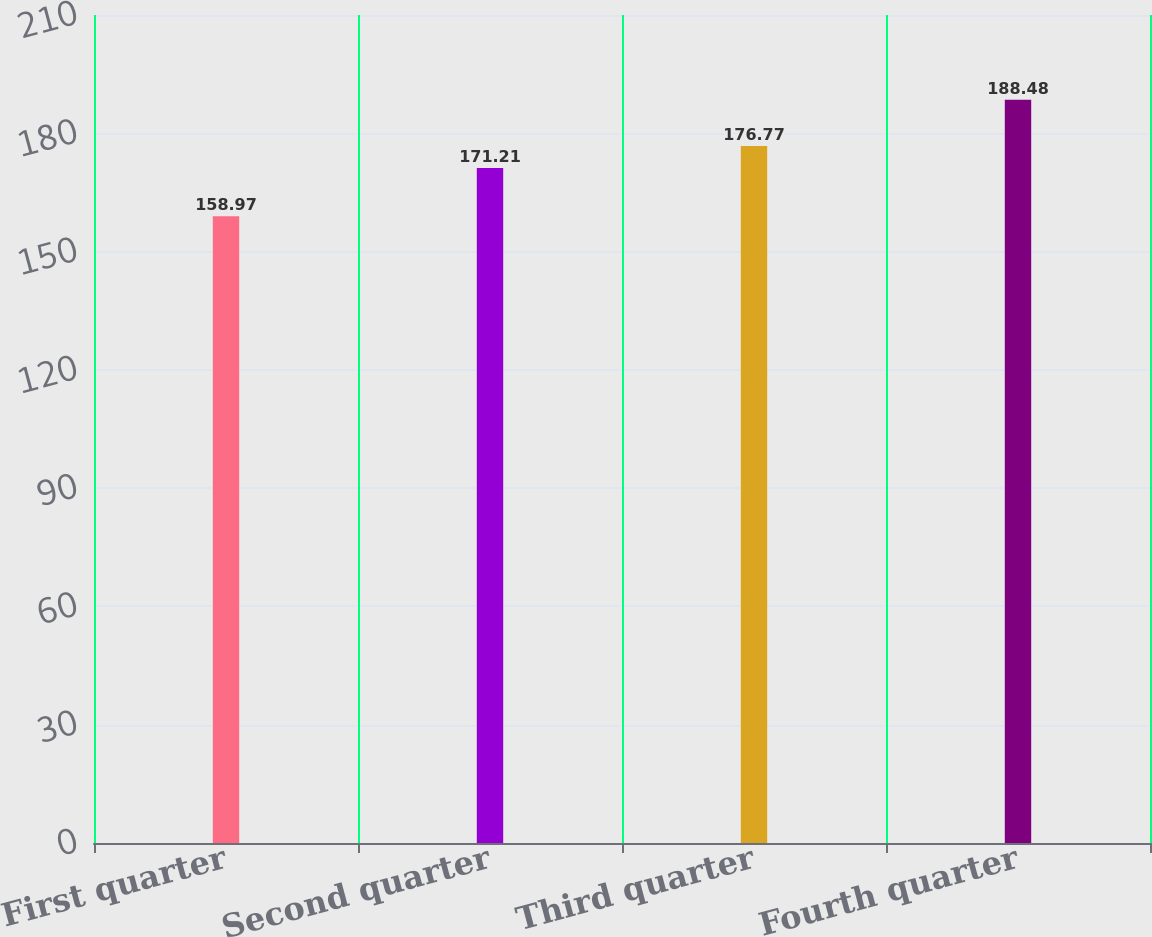Convert chart. <chart><loc_0><loc_0><loc_500><loc_500><bar_chart><fcel>First quarter<fcel>Second quarter<fcel>Third quarter<fcel>Fourth quarter<nl><fcel>158.97<fcel>171.21<fcel>176.77<fcel>188.48<nl></chart> 